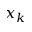<formula> <loc_0><loc_0><loc_500><loc_500>x _ { k }</formula> 